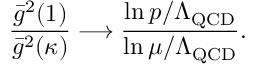Convert formula to latex. <formula><loc_0><loc_0><loc_500><loc_500>{ \frac { \bar { g } ^ { 2 } ( 1 ) } { \bar { g } ^ { 2 } ( \kappa ) } } \longrightarrow \frac { \ln p / \Lambda _ { Q C D } } { \ln \mu / \Lambda _ { Q C D } } .</formula> 